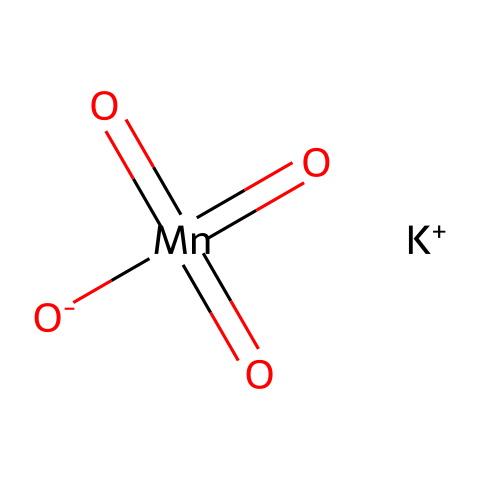How many oxygen atoms are present in this chemical? The chemical is potassium permanganate, represented by the formula [O-][Mn](=O)(=O)=O.[K+]. Analyzing the molecular arrangement shows there are four oxygen atoms connected to the manganese atom.
Answer: four What is the oxidation state of manganese in this compound? In the structure of potassium permanganate, manganese is connected to four oxygen atoms (three in double bonds and one with a negative charge). The oxidation state of manganese can be determined using standard oxidation states of oxygen (-2 each), giving a total of -6 from oxygen. The sum of oxidation states must equal the charge of the compound, which is neutral; thus, manganese must have an oxidation state of +7 to balance it.
Answer: +7 What is the charge of the potassium ion? The SMILES representation indicates that the potassium ion in potassium permanganate is represented as [K+], which clearly shows it has a positive charge.
Answer: +1 Which part of this chemical structure acts as a strong oxidizing agent? In potassium permanganate, the manganese in the +7 oxidation state is a key feature that contributes to its strong oxidizing properties, as this high oxidation state allows manganese to readily accept electrons during redox reactions.
Answer: manganese What type of bonds are present between manganese and oxygen in this compound? The SMILES representation shows that manganese forms one single bond with one oxygen and three double bonds with the other three oxygen atoms. This bonding arrangement of different types (single and double) indicates the chemical bonding specifics between these elements.
Answer: single and double bonds Why is potassium permanganate used in document authentication processes? Potassium permanganate is used in document authentication primarily due to its distinctive purple color, which becomes important in identifying forgeries. Additionally, its oxidizing properties can help in marking or altering documents during the authentication process, as changes can signify authenticity.
Answer: purple color 